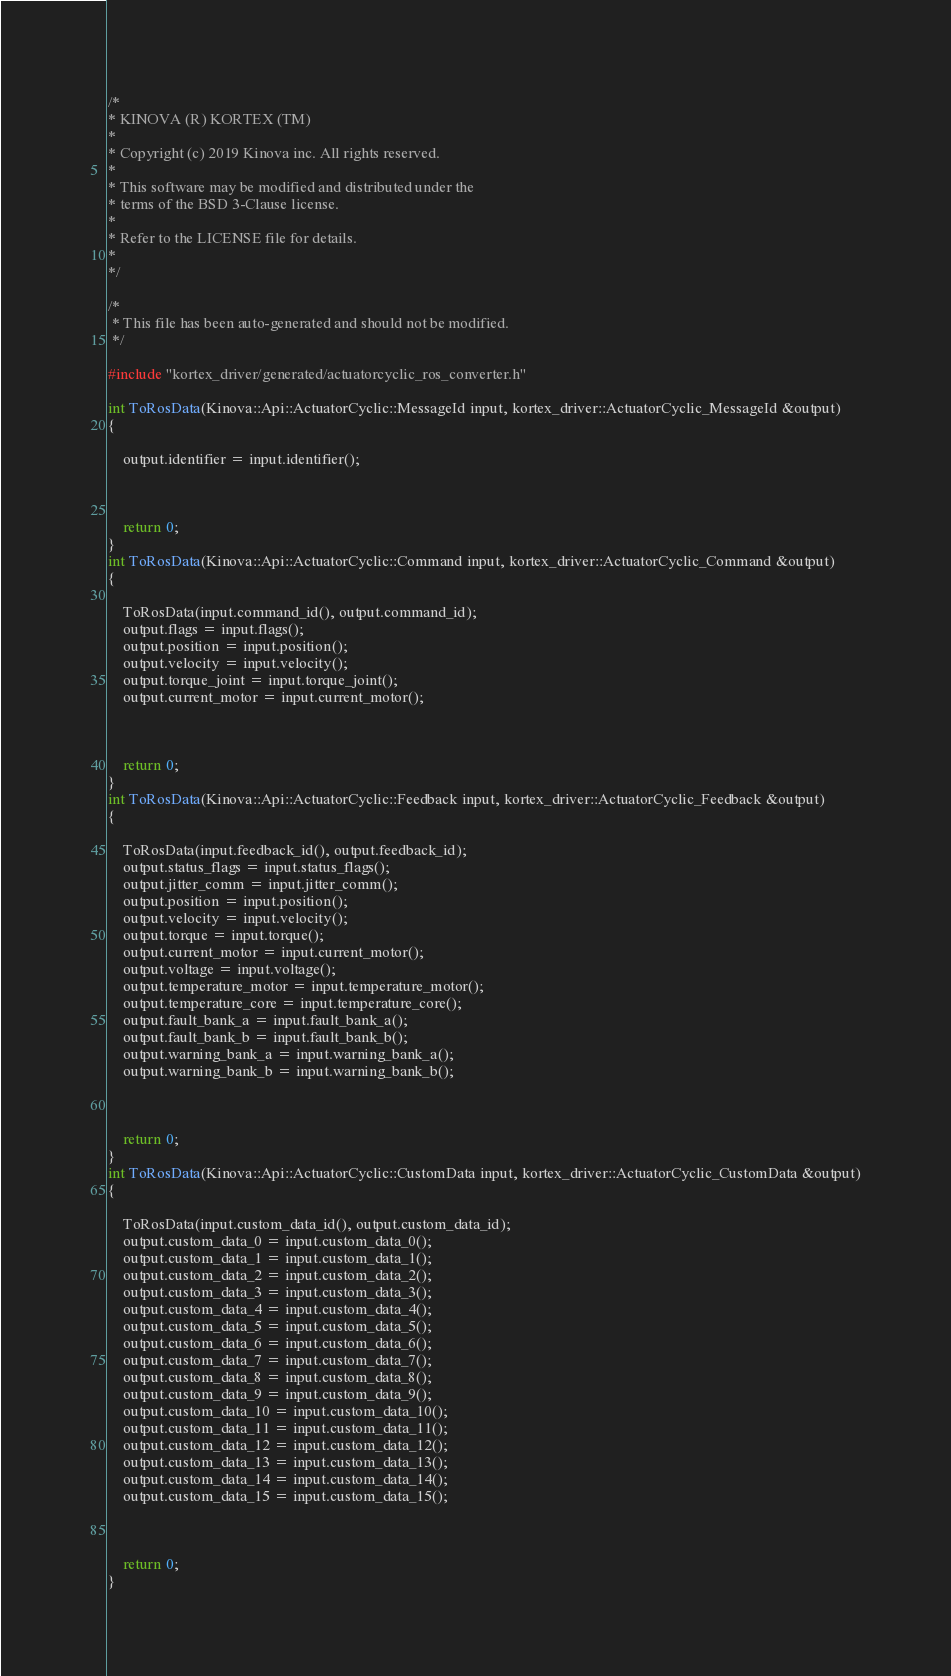<code> <loc_0><loc_0><loc_500><loc_500><_C++_>/*
* KINOVA (R) KORTEX (TM)
*
* Copyright (c) 2019 Kinova inc. All rights reserved.
*
* This software may be modified and distributed under the
* terms of the BSD 3-Clause license.
*
* Refer to the LICENSE file for details.
*
*/

/*
 * This file has been auto-generated and should not be modified.
 */
 
#include "kortex_driver/generated/actuatorcyclic_ros_converter.h"

int ToRosData(Kinova::Api::ActuatorCyclic::MessageId input, kortex_driver::ActuatorCyclic_MessageId &output)
{
	
	output.identifier = input.identifier();

	
	
	return 0;
}
int ToRosData(Kinova::Api::ActuatorCyclic::Command input, kortex_driver::ActuatorCyclic_Command &output)
{
	
	ToRosData(input.command_id(), output.command_id);
	output.flags = input.flags();
	output.position = input.position();
	output.velocity = input.velocity();
	output.torque_joint = input.torque_joint();
	output.current_motor = input.current_motor();

	
	
	return 0;
}
int ToRosData(Kinova::Api::ActuatorCyclic::Feedback input, kortex_driver::ActuatorCyclic_Feedback &output)
{
	
	ToRosData(input.feedback_id(), output.feedback_id);
	output.status_flags = input.status_flags();
	output.jitter_comm = input.jitter_comm();
	output.position = input.position();
	output.velocity = input.velocity();
	output.torque = input.torque();
	output.current_motor = input.current_motor();
	output.voltage = input.voltage();
	output.temperature_motor = input.temperature_motor();
	output.temperature_core = input.temperature_core();
	output.fault_bank_a = input.fault_bank_a();
	output.fault_bank_b = input.fault_bank_b();
	output.warning_bank_a = input.warning_bank_a();
	output.warning_bank_b = input.warning_bank_b();

	
	
	return 0;
}
int ToRosData(Kinova::Api::ActuatorCyclic::CustomData input, kortex_driver::ActuatorCyclic_CustomData &output)
{
	
	ToRosData(input.custom_data_id(), output.custom_data_id);
	output.custom_data_0 = input.custom_data_0();
	output.custom_data_1 = input.custom_data_1();
	output.custom_data_2 = input.custom_data_2();
	output.custom_data_3 = input.custom_data_3();
	output.custom_data_4 = input.custom_data_4();
	output.custom_data_5 = input.custom_data_5();
	output.custom_data_6 = input.custom_data_6();
	output.custom_data_7 = input.custom_data_7();
	output.custom_data_8 = input.custom_data_8();
	output.custom_data_9 = input.custom_data_9();
	output.custom_data_10 = input.custom_data_10();
	output.custom_data_11 = input.custom_data_11();
	output.custom_data_12 = input.custom_data_12();
	output.custom_data_13 = input.custom_data_13();
	output.custom_data_14 = input.custom_data_14();
	output.custom_data_15 = input.custom_data_15();

	
	
	return 0;
}
</code> 